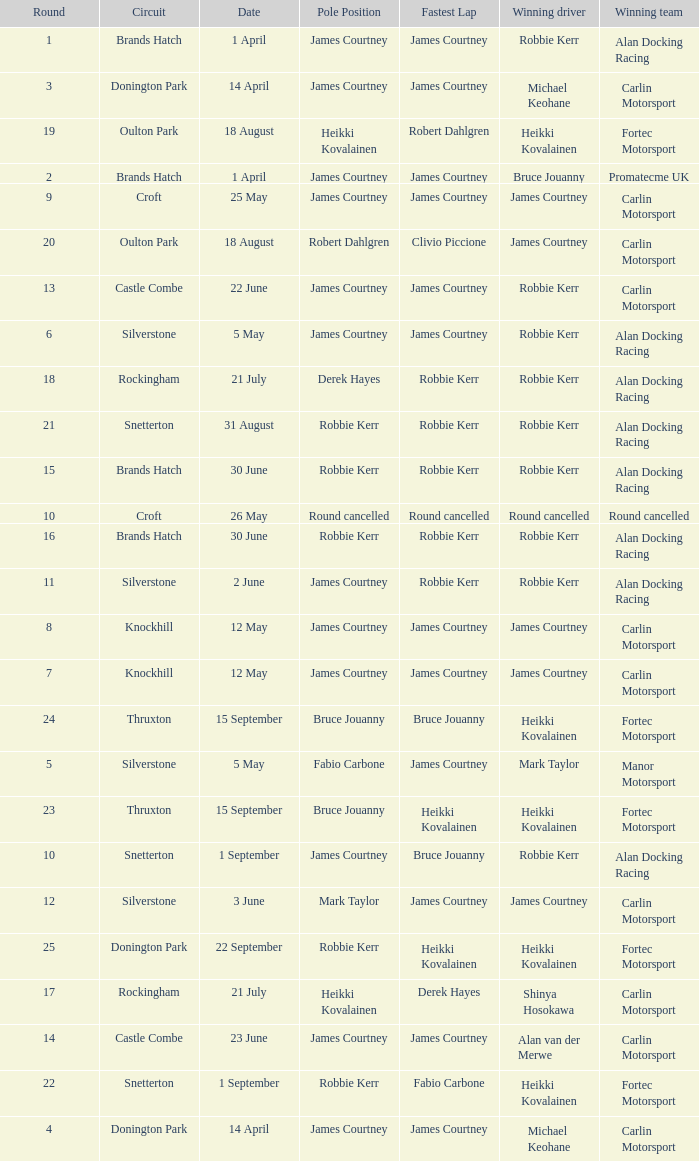What is every pole position for the Castle Combe circuit and Robbie Kerr is the winning driver? James Courtney. 